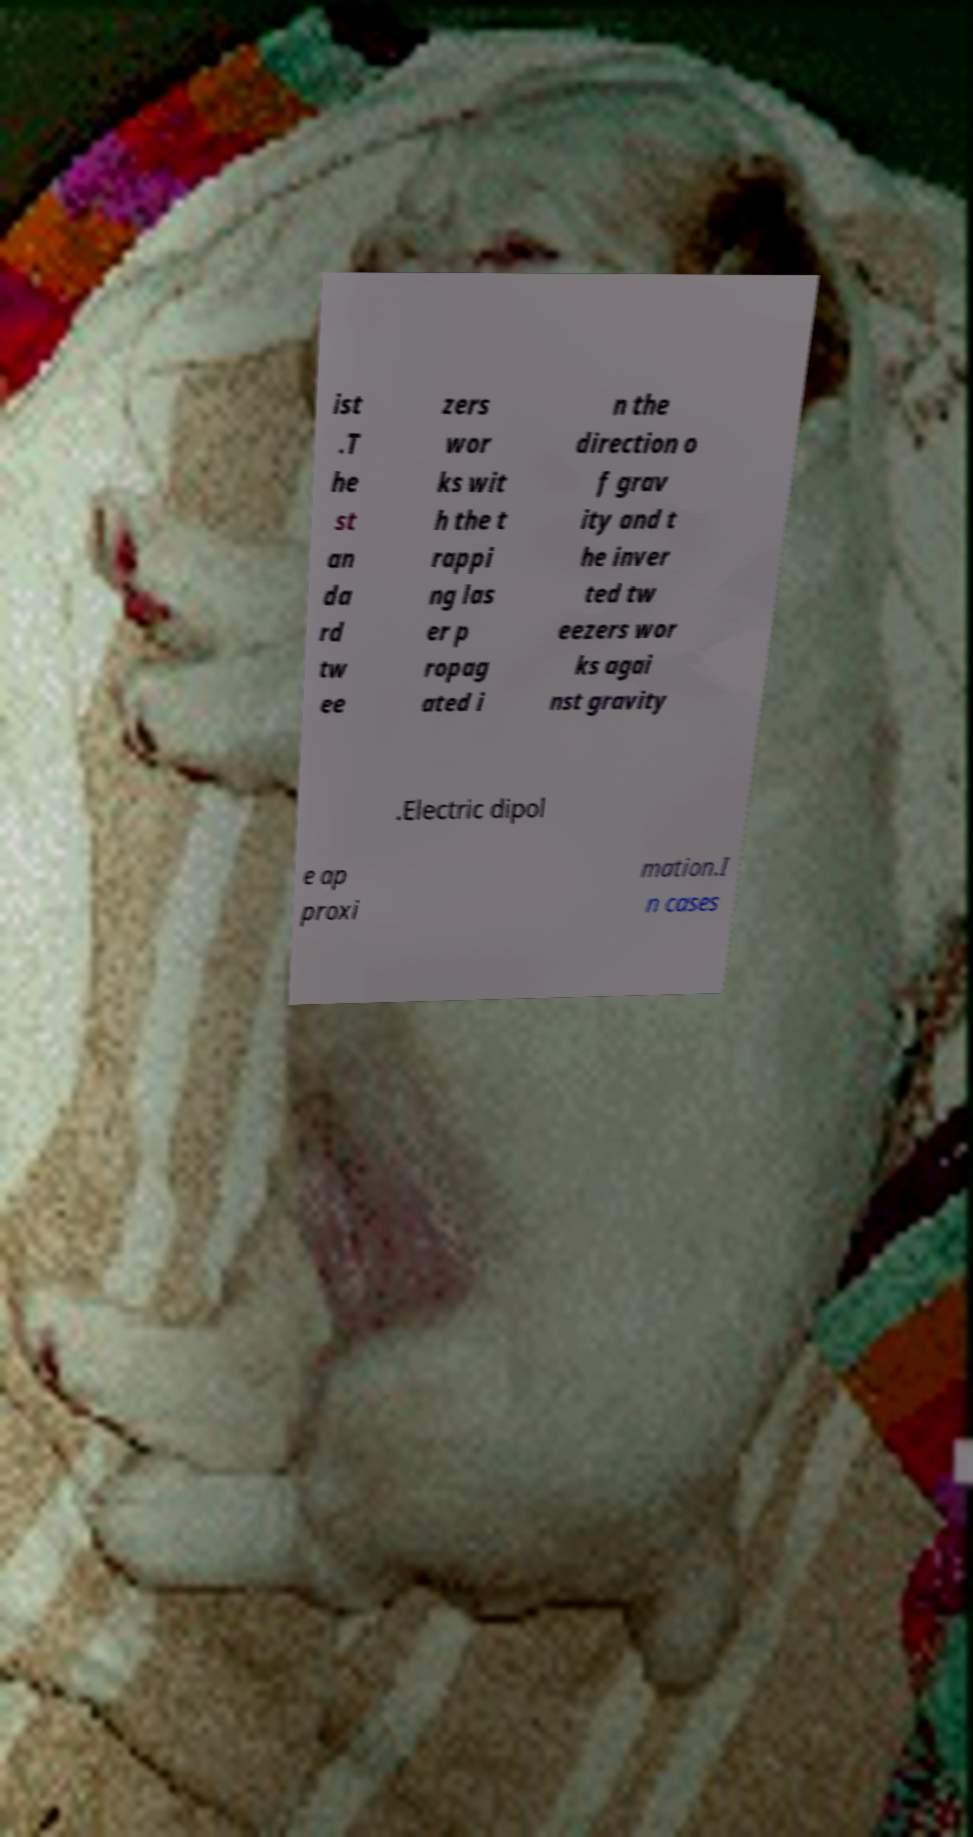Could you extract and type out the text from this image? ist .T he st an da rd tw ee zers wor ks wit h the t rappi ng las er p ropag ated i n the direction o f grav ity and t he inver ted tw eezers wor ks agai nst gravity .Electric dipol e ap proxi mation.I n cases 